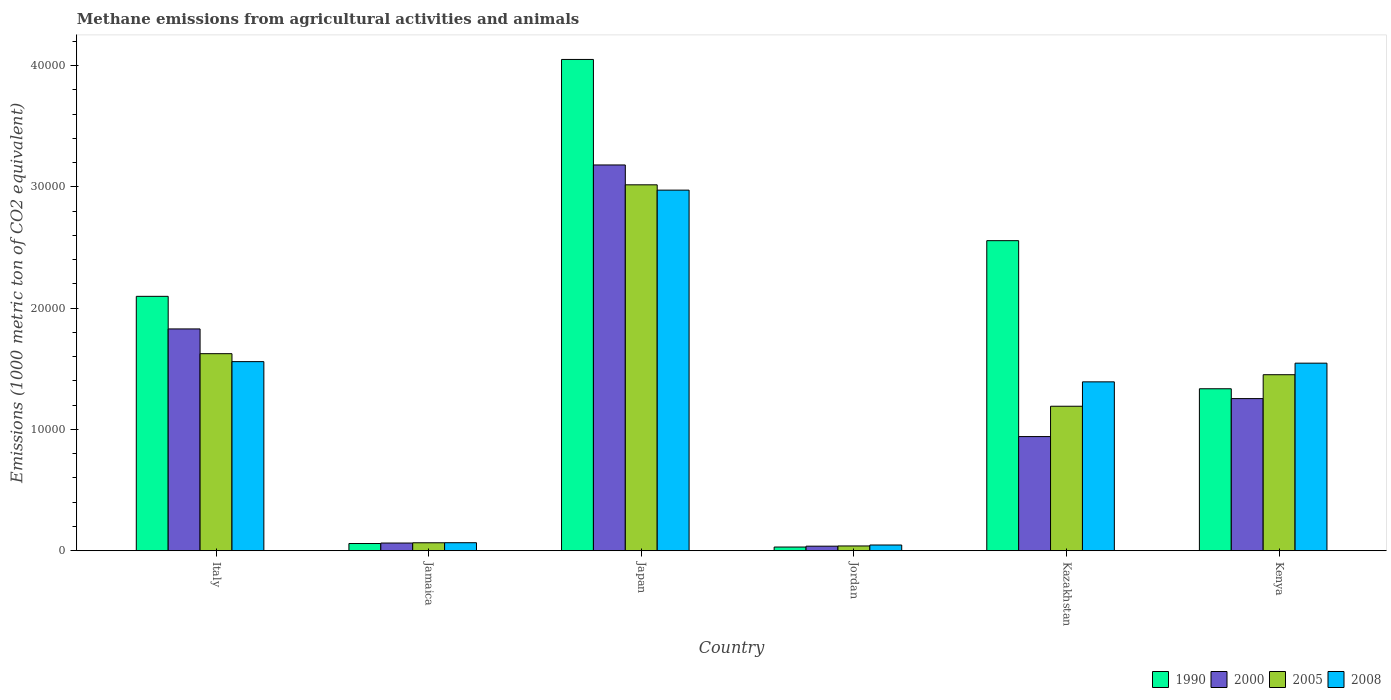How many groups of bars are there?
Provide a short and direct response. 6. How many bars are there on the 5th tick from the left?
Keep it short and to the point. 4. How many bars are there on the 3rd tick from the right?
Provide a succinct answer. 4. What is the label of the 4th group of bars from the left?
Your response must be concise. Jordan. What is the amount of methane emitted in 2008 in Jordan?
Provide a short and direct response. 470.4. Across all countries, what is the maximum amount of methane emitted in 2008?
Offer a terse response. 2.97e+04. Across all countries, what is the minimum amount of methane emitted in 1990?
Your answer should be compact. 303.3. In which country was the amount of methane emitted in 2008 maximum?
Ensure brevity in your answer.  Japan. In which country was the amount of methane emitted in 2000 minimum?
Your answer should be compact. Jordan. What is the total amount of methane emitted in 1990 in the graph?
Provide a short and direct response. 1.01e+05. What is the difference between the amount of methane emitted in 2005 in Jamaica and that in Kazakhstan?
Keep it short and to the point. -1.13e+04. What is the difference between the amount of methane emitted in 1990 in Jamaica and the amount of methane emitted in 2008 in Italy?
Your answer should be compact. -1.50e+04. What is the average amount of methane emitted in 2005 per country?
Offer a terse response. 1.23e+04. What is the difference between the amount of methane emitted of/in 2000 and amount of methane emitted of/in 2005 in Italy?
Keep it short and to the point. 2040.5. In how many countries, is the amount of methane emitted in 2000 greater than 16000 1000 metric ton?
Provide a succinct answer. 2. What is the ratio of the amount of methane emitted in 2005 in Japan to that in Jordan?
Keep it short and to the point. 77.01. Is the amount of methane emitted in 2000 in Jamaica less than that in Japan?
Your response must be concise. Yes. What is the difference between the highest and the second highest amount of methane emitted in 1990?
Keep it short and to the point. 1.49e+04. What is the difference between the highest and the lowest amount of methane emitted in 2000?
Keep it short and to the point. 3.14e+04. In how many countries, is the amount of methane emitted in 2000 greater than the average amount of methane emitted in 2000 taken over all countries?
Keep it short and to the point. 3. Is the sum of the amount of methane emitted in 1990 in Jamaica and Kazakhstan greater than the maximum amount of methane emitted in 2000 across all countries?
Give a very brief answer. No. Is it the case that in every country, the sum of the amount of methane emitted in 2005 and amount of methane emitted in 1990 is greater than the sum of amount of methane emitted in 2008 and amount of methane emitted in 2000?
Provide a succinct answer. No. What does the 1st bar from the right in Kenya represents?
Your answer should be compact. 2008. How many bars are there?
Your response must be concise. 24. What is the difference between two consecutive major ticks on the Y-axis?
Provide a succinct answer. 10000. Does the graph contain any zero values?
Provide a succinct answer. No. Does the graph contain grids?
Give a very brief answer. No. How many legend labels are there?
Offer a very short reply. 4. How are the legend labels stacked?
Your answer should be very brief. Horizontal. What is the title of the graph?
Your answer should be very brief. Methane emissions from agricultural activities and animals. Does "2009" appear as one of the legend labels in the graph?
Provide a short and direct response. No. What is the label or title of the X-axis?
Keep it short and to the point. Country. What is the label or title of the Y-axis?
Provide a succinct answer. Emissions (1000 metric ton of CO2 equivalent). What is the Emissions (1000 metric ton of CO2 equivalent) of 1990 in Italy?
Offer a very short reply. 2.10e+04. What is the Emissions (1000 metric ton of CO2 equivalent) of 2000 in Italy?
Keep it short and to the point. 1.83e+04. What is the Emissions (1000 metric ton of CO2 equivalent) in 2005 in Italy?
Your answer should be compact. 1.62e+04. What is the Emissions (1000 metric ton of CO2 equivalent) in 2008 in Italy?
Your response must be concise. 1.56e+04. What is the Emissions (1000 metric ton of CO2 equivalent) of 1990 in Jamaica?
Give a very brief answer. 593.6. What is the Emissions (1000 metric ton of CO2 equivalent) in 2000 in Jamaica?
Your answer should be compact. 632.9. What is the Emissions (1000 metric ton of CO2 equivalent) of 2005 in Jamaica?
Your answer should be very brief. 655.6. What is the Emissions (1000 metric ton of CO2 equivalent) of 2008 in Jamaica?
Your answer should be compact. 660.8. What is the Emissions (1000 metric ton of CO2 equivalent) of 1990 in Japan?
Provide a succinct answer. 4.05e+04. What is the Emissions (1000 metric ton of CO2 equivalent) of 2000 in Japan?
Give a very brief answer. 3.18e+04. What is the Emissions (1000 metric ton of CO2 equivalent) of 2005 in Japan?
Your response must be concise. 3.02e+04. What is the Emissions (1000 metric ton of CO2 equivalent) in 2008 in Japan?
Ensure brevity in your answer.  2.97e+04. What is the Emissions (1000 metric ton of CO2 equivalent) in 1990 in Jordan?
Provide a short and direct response. 303.3. What is the Emissions (1000 metric ton of CO2 equivalent) in 2000 in Jordan?
Provide a short and direct response. 374. What is the Emissions (1000 metric ton of CO2 equivalent) in 2005 in Jordan?
Your answer should be very brief. 391.8. What is the Emissions (1000 metric ton of CO2 equivalent) of 2008 in Jordan?
Make the answer very short. 470.4. What is the Emissions (1000 metric ton of CO2 equivalent) of 1990 in Kazakhstan?
Make the answer very short. 2.56e+04. What is the Emissions (1000 metric ton of CO2 equivalent) in 2000 in Kazakhstan?
Your response must be concise. 9412.4. What is the Emissions (1000 metric ton of CO2 equivalent) of 2005 in Kazakhstan?
Provide a succinct answer. 1.19e+04. What is the Emissions (1000 metric ton of CO2 equivalent) in 2008 in Kazakhstan?
Provide a succinct answer. 1.39e+04. What is the Emissions (1000 metric ton of CO2 equivalent) in 1990 in Kenya?
Offer a terse response. 1.34e+04. What is the Emissions (1000 metric ton of CO2 equivalent) of 2000 in Kenya?
Give a very brief answer. 1.25e+04. What is the Emissions (1000 metric ton of CO2 equivalent) in 2005 in Kenya?
Your answer should be very brief. 1.45e+04. What is the Emissions (1000 metric ton of CO2 equivalent) in 2008 in Kenya?
Make the answer very short. 1.55e+04. Across all countries, what is the maximum Emissions (1000 metric ton of CO2 equivalent) in 1990?
Your answer should be very brief. 4.05e+04. Across all countries, what is the maximum Emissions (1000 metric ton of CO2 equivalent) of 2000?
Keep it short and to the point. 3.18e+04. Across all countries, what is the maximum Emissions (1000 metric ton of CO2 equivalent) of 2005?
Offer a very short reply. 3.02e+04. Across all countries, what is the maximum Emissions (1000 metric ton of CO2 equivalent) in 2008?
Offer a very short reply. 2.97e+04. Across all countries, what is the minimum Emissions (1000 metric ton of CO2 equivalent) in 1990?
Offer a very short reply. 303.3. Across all countries, what is the minimum Emissions (1000 metric ton of CO2 equivalent) of 2000?
Provide a succinct answer. 374. Across all countries, what is the minimum Emissions (1000 metric ton of CO2 equivalent) of 2005?
Your answer should be compact. 391.8. Across all countries, what is the minimum Emissions (1000 metric ton of CO2 equivalent) of 2008?
Your answer should be compact. 470.4. What is the total Emissions (1000 metric ton of CO2 equivalent) in 1990 in the graph?
Your answer should be compact. 1.01e+05. What is the total Emissions (1000 metric ton of CO2 equivalent) in 2000 in the graph?
Offer a very short reply. 7.31e+04. What is the total Emissions (1000 metric ton of CO2 equivalent) of 2005 in the graph?
Your response must be concise. 7.39e+04. What is the total Emissions (1000 metric ton of CO2 equivalent) of 2008 in the graph?
Offer a terse response. 7.58e+04. What is the difference between the Emissions (1000 metric ton of CO2 equivalent) of 1990 in Italy and that in Jamaica?
Give a very brief answer. 2.04e+04. What is the difference between the Emissions (1000 metric ton of CO2 equivalent) in 2000 in Italy and that in Jamaica?
Provide a succinct answer. 1.77e+04. What is the difference between the Emissions (1000 metric ton of CO2 equivalent) in 2005 in Italy and that in Jamaica?
Make the answer very short. 1.56e+04. What is the difference between the Emissions (1000 metric ton of CO2 equivalent) in 2008 in Italy and that in Jamaica?
Your answer should be very brief. 1.49e+04. What is the difference between the Emissions (1000 metric ton of CO2 equivalent) of 1990 in Italy and that in Japan?
Provide a short and direct response. -1.95e+04. What is the difference between the Emissions (1000 metric ton of CO2 equivalent) of 2000 in Italy and that in Japan?
Provide a succinct answer. -1.35e+04. What is the difference between the Emissions (1000 metric ton of CO2 equivalent) of 2005 in Italy and that in Japan?
Your answer should be very brief. -1.39e+04. What is the difference between the Emissions (1000 metric ton of CO2 equivalent) of 2008 in Italy and that in Japan?
Give a very brief answer. -1.41e+04. What is the difference between the Emissions (1000 metric ton of CO2 equivalent) in 1990 in Italy and that in Jordan?
Offer a terse response. 2.07e+04. What is the difference between the Emissions (1000 metric ton of CO2 equivalent) of 2000 in Italy and that in Jordan?
Your response must be concise. 1.79e+04. What is the difference between the Emissions (1000 metric ton of CO2 equivalent) of 2005 in Italy and that in Jordan?
Your response must be concise. 1.59e+04. What is the difference between the Emissions (1000 metric ton of CO2 equivalent) of 2008 in Italy and that in Jordan?
Offer a very short reply. 1.51e+04. What is the difference between the Emissions (1000 metric ton of CO2 equivalent) in 1990 in Italy and that in Kazakhstan?
Your answer should be compact. -4591. What is the difference between the Emissions (1000 metric ton of CO2 equivalent) in 2000 in Italy and that in Kazakhstan?
Give a very brief answer. 8875.7. What is the difference between the Emissions (1000 metric ton of CO2 equivalent) in 2005 in Italy and that in Kazakhstan?
Your answer should be compact. 4333.9. What is the difference between the Emissions (1000 metric ton of CO2 equivalent) in 2008 in Italy and that in Kazakhstan?
Provide a short and direct response. 1666.6. What is the difference between the Emissions (1000 metric ton of CO2 equivalent) in 1990 in Italy and that in Kenya?
Provide a short and direct response. 7620.9. What is the difference between the Emissions (1000 metric ton of CO2 equivalent) of 2000 in Italy and that in Kenya?
Keep it short and to the point. 5744.5. What is the difference between the Emissions (1000 metric ton of CO2 equivalent) in 2005 in Italy and that in Kenya?
Your response must be concise. 1734.9. What is the difference between the Emissions (1000 metric ton of CO2 equivalent) in 2008 in Italy and that in Kenya?
Your response must be concise. 125.7. What is the difference between the Emissions (1000 metric ton of CO2 equivalent) of 1990 in Jamaica and that in Japan?
Keep it short and to the point. -3.99e+04. What is the difference between the Emissions (1000 metric ton of CO2 equivalent) in 2000 in Jamaica and that in Japan?
Ensure brevity in your answer.  -3.12e+04. What is the difference between the Emissions (1000 metric ton of CO2 equivalent) of 2005 in Jamaica and that in Japan?
Ensure brevity in your answer.  -2.95e+04. What is the difference between the Emissions (1000 metric ton of CO2 equivalent) in 2008 in Jamaica and that in Japan?
Provide a succinct answer. -2.91e+04. What is the difference between the Emissions (1000 metric ton of CO2 equivalent) of 1990 in Jamaica and that in Jordan?
Provide a short and direct response. 290.3. What is the difference between the Emissions (1000 metric ton of CO2 equivalent) in 2000 in Jamaica and that in Jordan?
Offer a very short reply. 258.9. What is the difference between the Emissions (1000 metric ton of CO2 equivalent) of 2005 in Jamaica and that in Jordan?
Ensure brevity in your answer.  263.8. What is the difference between the Emissions (1000 metric ton of CO2 equivalent) in 2008 in Jamaica and that in Jordan?
Your answer should be very brief. 190.4. What is the difference between the Emissions (1000 metric ton of CO2 equivalent) of 1990 in Jamaica and that in Kazakhstan?
Provide a succinct answer. -2.50e+04. What is the difference between the Emissions (1000 metric ton of CO2 equivalent) of 2000 in Jamaica and that in Kazakhstan?
Provide a short and direct response. -8779.5. What is the difference between the Emissions (1000 metric ton of CO2 equivalent) of 2005 in Jamaica and that in Kazakhstan?
Your response must be concise. -1.13e+04. What is the difference between the Emissions (1000 metric ton of CO2 equivalent) in 2008 in Jamaica and that in Kazakhstan?
Ensure brevity in your answer.  -1.33e+04. What is the difference between the Emissions (1000 metric ton of CO2 equivalent) in 1990 in Jamaica and that in Kenya?
Provide a succinct answer. -1.28e+04. What is the difference between the Emissions (1000 metric ton of CO2 equivalent) in 2000 in Jamaica and that in Kenya?
Make the answer very short. -1.19e+04. What is the difference between the Emissions (1000 metric ton of CO2 equivalent) in 2005 in Jamaica and that in Kenya?
Keep it short and to the point. -1.39e+04. What is the difference between the Emissions (1000 metric ton of CO2 equivalent) in 2008 in Jamaica and that in Kenya?
Provide a succinct answer. -1.48e+04. What is the difference between the Emissions (1000 metric ton of CO2 equivalent) in 1990 in Japan and that in Jordan?
Make the answer very short. 4.02e+04. What is the difference between the Emissions (1000 metric ton of CO2 equivalent) in 2000 in Japan and that in Jordan?
Your response must be concise. 3.14e+04. What is the difference between the Emissions (1000 metric ton of CO2 equivalent) in 2005 in Japan and that in Jordan?
Make the answer very short. 2.98e+04. What is the difference between the Emissions (1000 metric ton of CO2 equivalent) in 2008 in Japan and that in Jordan?
Keep it short and to the point. 2.93e+04. What is the difference between the Emissions (1000 metric ton of CO2 equivalent) in 1990 in Japan and that in Kazakhstan?
Keep it short and to the point. 1.49e+04. What is the difference between the Emissions (1000 metric ton of CO2 equivalent) in 2000 in Japan and that in Kazakhstan?
Provide a short and direct response. 2.24e+04. What is the difference between the Emissions (1000 metric ton of CO2 equivalent) in 2005 in Japan and that in Kazakhstan?
Give a very brief answer. 1.83e+04. What is the difference between the Emissions (1000 metric ton of CO2 equivalent) in 2008 in Japan and that in Kazakhstan?
Your answer should be very brief. 1.58e+04. What is the difference between the Emissions (1000 metric ton of CO2 equivalent) of 1990 in Japan and that in Kenya?
Your answer should be compact. 2.72e+04. What is the difference between the Emissions (1000 metric ton of CO2 equivalent) in 2000 in Japan and that in Kenya?
Ensure brevity in your answer.  1.93e+04. What is the difference between the Emissions (1000 metric ton of CO2 equivalent) of 2005 in Japan and that in Kenya?
Give a very brief answer. 1.57e+04. What is the difference between the Emissions (1000 metric ton of CO2 equivalent) in 2008 in Japan and that in Kenya?
Your response must be concise. 1.43e+04. What is the difference between the Emissions (1000 metric ton of CO2 equivalent) of 1990 in Jordan and that in Kazakhstan?
Provide a short and direct response. -2.53e+04. What is the difference between the Emissions (1000 metric ton of CO2 equivalent) in 2000 in Jordan and that in Kazakhstan?
Make the answer very short. -9038.4. What is the difference between the Emissions (1000 metric ton of CO2 equivalent) of 2005 in Jordan and that in Kazakhstan?
Make the answer very short. -1.15e+04. What is the difference between the Emissions (1000 metric ton of CO2 equivalent) of 2008 in Jordan and that in Kazakhstan?
Give a very brief answer. -1.35e+04. What is the difference between the Emissions (1000 metric ton of CO2 equivalent) in 1990 in Jordan and that in Kenya?
Ensure brevity in your answer.  -1.31e+04. What is the difference between the Emissions (1000 metric ton of CO2 equivalent) of 2000 in Jordan and that in Kenya?
Your answer should be compact. -1.22e+04. What is the difference between the Emissions (1000 metric ton of CO2 equivalent) of 2005 in Jordan and that in Kenya?
Your response must be concise. -1.41e+04. What is the difference between the Emissions (1000 metric ton of CO2 equivalent) of 2008 in Jordan and that in Kenya?
Provide a short and direct response. -1.50e+04. What is the difference between the Emissions (1000 metric ton of CO2 equivalent) in 1990 in Kazakhstan and that in Kenya?
Your answer should be compact. 1.22e+04. What is the difference between the Emissions (1000 metric ton of CO2 equivalent) in 2000 in Kazakhstan and that in Kenya?
Keep it short and to the point. -3131.2. What is the difference between the Emissions (1000 metric ton of CO2 equivalent) in 2005 in Kazakhstan and that in Kenya?
Provide a short and direct response. -2599. What is the difference between the Emissions (1000 metric ton of CO2 equivalent) of 2008 in Kazakhstan and that in Kenya?
Ensure brevity in your answer.  -1540.9. What is the difference between the Emissions (1000 metric ton of CO2 equivalent) of 1990 in Italy and the Emissions (1000 metric ton of CO2 equivalent) of 2000 in Jamaica?
Offer a very short reply. 2.03e+04. What is the difference between the Emissions (1000 metric ton of CO2 equivalent) of 1990 in Italy and the Emissions (1000 metric ton of CO2 equivalent) of 2005 in Jamaica?
Your answer should be compact. 2.03e+04. What is the difference between the Emissions (1000 metric ton of CO2 equivalent) in 1990 in Italy and the Emissions (1000 metric ton of CO2 equivalent) in 2008 in Jamaica?
Ensure brevity in your answer.  2.03e+04. What is the difference between the Emissions (1000 metric ton of CO2 equivalent) of 2000 in Italy and the Emissions (1000 metric ton of CO2 equivalent) of 2005 in Jamaica?
Offer a terse response. 1.76e+04. What is the difference between the Emissions (1000 metric ton of CO2 equivalent) of 2000 in Italy and the Emissions (1000 metric ton of CO2 equivalent) of 2008 in Jamaica?
Provide a short and direct response. 1.76e+04. What is the difference between the Emissions (1000 metric ton of CO2 equivalent) in 2005 in Italy and the Emissions (1000 metric ton of CO2 equivalent) in 2008 in Jamaica?
Offer a terse response. 1.56e+04. What is the difference between the Emissions (1000 metric ton of CO2 equivalent) of 1990 in Italy and the Emissions (1000 metric ton of CO2 equivalent) of 2000 in Japan?
Your answer should be very brief. -1.08e+04. What is the difference between the Emissions (1000 metric ton of CO2 equivalent) of 1990 in Italy and the Emissions (1000 metric ton of CO2 equivalent) of 2005 in Japan?
Give a very brief answer. -9195.3. What is the difference between the Emissions (1000 metric ton of CO2 equivalent) of 1990 in Italy and the Emissions (1000 metric ton of CO2 equivalent) of 2008 in Japan?
Provide a short and direct response. -8758. What is the difference between the Emissions (1000 metric ton of CO2 equivalent) of 2000 in Italy and the Emissions (1000 metric ton of CO2 equivalent) of 2005 in Japan?
Ensure brevity in your answer.  -1.19e+04. What is the difference between the Emissions (1000 metric ton of CO2 equivalent) in 2000 in Italy and the Emissions (1000 metric ton of CO2 equivalent) in 2008 in Japan?
Provide a short and direct response. -1.14e+04. What is the difference between the Emissions (1000 metric ton of CO2 equivalent) of 2005 in Italy and the Emissions (1000 metric ton of CO2 equivalent) of 2008 in Japan?
Keep it short and to the point. -1.35e+04. What is the difference between the Emissions (1000 metric ton of CO2 equivalent) of 1990 in Italy and the Emissions (1000 metric ton of CO2 equivalent) of 2000 in Jordan?
Offer a very short reply. 2.06e+04. What is the difference between the Emissions (1000 metric ton of CO2 equivalent) in 1990 in Italy and the Emissions (1000 metric ton of CO2 equivalent) in 2005 in Jordan?
Your answer should be compact. 2.06e+04. What is the difference between the Emissions (1000 metric ton of CO2 equivalent) in 1990 in Italy and the Emissions (1000 metric ton of CO2 equivalent) in 2008 in Jordan?
Make the answer very short. 2.05e+04. What is the difference between the Emissions (1000 metric ton of CO2 equivalent) in 2000 in Italy and the Emissions (1000 metric ton of CO2 equivalent) in 2005 in Jordan?
Ensure brevity in your answer.  1.79e+04. What is the difference between the Emissions (1000 metric ton of CO2 equivalent) in 2000 in Italy and the Emissions (1000 metric ton of CO2 equivalent) in 2008 in Jordan?
Provide a short and direct response. 1.78e+04. What is the difference between the Emissions (1000 metric ton of CO2 equivalent) in 2005 in Italy and the Emissions (1000 metric ton of CO2 equivalent) in 2008 in Jordan?
Your response must be concise. 1.58e+04. What is the difference between the Emissions (1000 metric ton of CO2 equivalent) in 1990 in Italy and the Emissions (1000 metric ton of CO2 equivalent) in 2000 in Kazakhstan?
Offer a very short reply. 1.16e+04. What is the difference between the Emissions (1000 metric ton of CO2 equivalent) in 1990 in Italy and the Emissions (1000 metric ton of CO2 equivalent) in 2005 in Kazakhstan?
Keep it short and to the point. 9061.7. What is the difference between the Emissions (1000 metric ton of CO2 equivalent) in 1990 in Italy and the Emissions (1000 metric ton of CO2 equivalent) in 2008 in Kazakhstan?
Provide a short and direct response. 7050.5. What is the difference between the Emissions (1000 metric ton of CO2 equivalent) in 2000 in Italy and the Emissions (1000 metric ton of CO2 equivalent) in 2005 in Kazakhstan?
Your answer should be compact. 6374.4. What is the difference between the Emissions (1000 metric ton of CO2 equivalent) in 2000 in Italy and the Emissions (1000 metric ton of CO2 equivalent) in 2008 in Kazakhstan?
Ensure brevity in your answer.  4363.2. What is the difference between the Emissions (1000 metric ton of CO2 equivalent) in 2005 in Italy and the Emissions (1000 metric ton of CO2 equivalent) in 2008 in Kazakhstan?
Offer a very short reply. 2322.7. What is the difference between the Emissions (1000 metric ton of CO2 equivalent) of 1990 in Italy and the Emissions (1000 metric ton of CO2 equivalent) of 2000 in Kenya?
Your answer should be very brief. 8431.8. What is the difference between the Emissions (1000 metric ton of CO2 equivalent) of 1990 in Italy and the Emissions (1000 metric ton of CO2 equivalent) of 2005 in Kenya?
Your answer should be compact. 6462.7. What is the difference between the Emissions (1000 metric ton of CO2 equivalent) of 1990 in Italy and the Emissions (1000 metric ton of CO2 equivalent) of 2008 in Kenya?
Give a very brief answer. 5509.6. What is the difference between the Emissions (1000 metric ton of CO2 equivalent) in 2000 in Italy and the Emissions (1000 metric ton of CO2 equivalent) in 2005 in Kenya?
Your answer should be compact. 3775.4. What is the difference between the Emissions (1000 metric ton of CO2 equivalent) in 2000 in Italy and the Emissions (1000 metric ton of CO2 equivalent) in 2008 in Kenya?
Ensure brevity in your answer.  2822.3. What is the difference between the Emissions (1000 metric ton of CO2 equivalent) in 2005 in Italy and the Emissions (1000 metric ton of CO2 equivalent) in 2008 in Kenya?
Provide a succinct answer. 781.8. What is the difference between the Emissions (1000 metric ton of CO2 equivalent) in 1990 in Jamaica and the Emissions (1000 metric ton of CO2 equivalent) in 2000 in Japan?
Provide a short and direct response. -3.12e+04. What is the difference between the Emissions (1000 metric ton of CO2 equivalent) in 1990 in Jamaica and the Emissions (1000 metric ton of CO2 equivalent) in 2005 in Japan?
Give a very brief answer. -2.96e+04. What is the difference between the Emissions (1000 metric ton of CO2 equivalent) of 1990 in Jamaica and the Emissions (1000 metric ton of CO2 equivalent) of 2008 in Japan?
Offer a terse response. -2.91e+04. What is the difference between the Emissions (1000 metric ton of CO2 equivalent) in 2000 in Jamaica and the Emissions (1000 metric ton of CO2 equivalent) in 2005 in Japan?
Provide a succinct answer. -2.95e+04. What is the difference between the Emissions (1000 metric ton of CO2 equivalent) of 2000 in Jamaica and the Emissions (1000 metric ton of CO2 equivalent) of 2008 in Japan?
Your answer should be very brief. -2.91e+04. What is the difference between the Emissions (1000 metric ton of CO2 equivalent) in 2005 in Jamaica and the Emissions (1000 metric ton of CO2 equivalent) in 2008 in Japan?
Your answer should be very brief. -2.91e+04. What is the difference between the Emissions (1000 metric ton of CO2 equivalent) of 1990 in Jamaica and the Emissions (1000 metric ton of CO2 equivalent) of 2000 in Jordan?
Provide a short and direct response. 219.6. What is the difference between the Emissions (1000 metric ton of CO2 equivalent) in 1990 in Jamaica and the Emissions (1000 metric ton of CO2 equivalent) in 2005 in Jordan?
Offer a very short reply. 201.8. What is the difference between the Emissions (1000 metric ton of CO2 equivalent) in 1990 in Jamaica and the Emissions (1000 metric ton of CO2 equivalent) in 2008 in Jordan?
Provide a succinct answer. 123.2. What is the difference between the Emissions (1000 metric ton of CO2 equivalent) of 2000 in Jamaica and the Emissions (1000 metric ton of CO2 equivalent) of 2005 in Jordan?
Give a very brief answer. 241.1. What is the difference between the Emissions (1000 metric ton of CO2 equivalent) of 2000 in Jamaica and the Emissions (1000 metric ton of CO2 equivalent) of 2008 in Jordan?
Ensure brevity in your answer.  162.5. What is the difference between the Emissions (1000 metric ton of CO2 equivalent) in 2005 in Jamaica and the Emissions (1000 metric ton of CO2 equivalent) in 2008 in Jordan?
Ensure brevity in your answer.  185.2. What is the difference between the Emissions (1000 metric ton of CO2 equivalent) of 1990 in Jamaica and the Emissions (1000 metric ton of CO2 equivalent) of 2000 in Kazakhstan?
Your answer should be very brief. -8818.8. What is the difference between the Emissions (1000 metric ton of CO2 equivalent) in 1990 in Jamaica and the Emissions (1000 metric ton of CO2 equivalent) in 2005 in Kazakhstan?
Your answer should be very brief. -1.13e+04. What is the difference between the Emissions (1000 metric ton of CO2 equivalent) of 1990 in Jamaica and the Emissions (1000 metric ton of CO2 equivalent) of 2008 in Kazakhstan?
Offer a terse response. -1.33e+04. What is the difference between the Emissions (1000 metric ton of CO2 equivalent) in 2000 in Jamaica and the Emissions (1000 metric ton of CO2 equivalent) in 2005 in Kazakhstan?
Give a very brief answer. -1.13e+04. What is the difference between the Emissions (1000 metric ton of CO2 equivalent) in 2000 in Jamaica and the Emissions (1000 metric ton of CO2 equivalent) in 2008 in Kazakhstan?
Your answer should be compact. -1.33e+04. What is the difference between the Emissions (1000 metric ton of CO2 equivalent) of 2005 in Jamaica and the Emissions (1000 metric ton of CO2 equivalent) of 2008 in Kazakhstan?
Make the answer very short. -1.33e+04. What is the difference between the Emissions (1000 metric ton of CO2 equivalent) of 1990 in Jamaica and the Emissions (1000 metric ton of CO2 equivalent) of 2000 in Kenya?
Give a very brief answer. -1.20e+04. What is the difference between the Emissions (1000 metric ton of CO2 equivalent) in 1990 in Jamaica and the Emissions (1000 metric ton of CO2 equivalent) in 2005 in Kenya?
Offer a very short reply. -1.39e+04. What is the difference between the Emissions (1000 metric ton of CO2 equivalent) of 1990 in Jamaica and the Emissions (1000 metric ton of CO2 equivalent) of 2008 in Kenya?
Your answer should be compact. -1.49e+04. What is the difference between the Emissions (1000 metric ton of CO2 equivalent) in 2000 in Jamaica and the Emissions (1000 metric ton of CO2 equivalent) in 2005 in Kenya?
Provide a short and direct response. -1.39e+04. What is the difference between the Emissions (1000 metric ton of CO2 equivalent) in 2000 in Jamaica and the Emissions (1000 metric ton of CO2 equivalent) in 2008 in Kenya?
Ensure brevity in your answer.  -1.48e+04. What is the difference between the Emissions (1000 metric ton of CO2 equivalent) in 2005 in Jamaica and the Emissions (1000 metric ton of CO2 equivalent) in 2008 in Kenya?
Offer a very short reply. -1.48e+04. What is the difference between the Emissions (1000 metric ton of CO2 equivalent) in 1990 in Japan and the Emissions (1000 metric ton of CO2 equivalent) in 2000 in Jordan?
Provide a short and direct response. 4.01e+04. What is the difference between the Emissions (1000 metric ton of CO2 equivalent) of 1990 in Japan and the Emissions (1000 metric ton of CO2 equivalent) of 2005 in Jordan?
Your response must be concise. 4.01e+04. What is the difference between the Emissions (1000 metric ton of CO2 equivalent) of 1990 in Japan and the Emissions (1000 metric ton of CO2 equivalent) of 2008 in Jordan?
Your response must be concise. 4.00e+04. What is the difference between the Emissions (1000 metric ton of CO2 equivalent) in 2000 in Japan and the Emissions (1000 metric ton of CO2 equivalent) in 2005 in Jordan?
Make the answer very short. 3.14e+04. What is the difference between the Emissions (1000 metric ton of CO2 equivalent) of 2000 in Japan and the Emissions (1000 metric ton of CO2 equivalent) of 2008 in Jordan?
Make the answer very short. 3.13e+04. What is the difference between the Emissions (1000 metric ton of CO2 equivalent) of 2005 in Japan and the Emissions (1000 metric ton of CO2 equivalent) of 2008 in Jordan?
Your response must be concise. 2.97e+04. What is the difference between the Emissions (1000 metric ton of CO2 equivalent) of 1990 in Japan and the Emissions (1000 metric ton of CO2 equivalent) of 2000 in Kazakhstan?
Make the answer very short. 3.11e+04. What is the difference between the Emissions (1000 metric ton of CO2 equivalent) in 1990 in Japan and the Emissions (1000 metric ton of CO2 equivalent) in 2005 in Kazakhstan?
Ensure brevity in your answer.  2.86e+04. What is the difference between the Emissions (1000 metric ton of CO2 equivalent) in 1990 in Japan and the Emissions (1000 metric ton of CO2 equivalent) in 2008 in Kazakhstan?
Provide a succinct answer. 2.66e+04. What is the difference between the Emissions (1000 metric ton of CO2 equivalent) of 2000 in Japan and the Emissions (1000 metric ton of CO2 equivalent) of 2005 in Kazakhstan?
Make the answer very short. 1.99e+04. What is the difference between the Emissions (1000 metric ton of CO2 equivalent) of 2000 in Japan and the Emissions (1000 metric ton of CO2 equivalent) of 2008 in Kazakhstan?
Keep it short and to the point. 1.79e+04. What is the difference between the Emissions (1000 metric ton of CO2 equivalent) in 2005 in Japan and the Emissions (1000 metric ton of CO2 equivalent) in 2008 in Kazakhstan?
Give a very brief answer. 1.62e+04. What is the difference between the Emissions (1000 metric ton of CO2 equivalent) in 1990 in Japan and the Emissions (1000 metric ton of CO2 equivalent) in 2000 in Kenya?
Give a very brief answer. 2.80e+04. What is the difference between the Emissions (1000 metric ton of CO2 equivalent) of 1990 in Japan and the Emissions (1000 metric ton of CO2 equivalent) of 2005 in Kenya?
Make the answer very short. 2.60e+04. What is the difference between the Emissions (1000 metric ton of CO2 equivalent) in 1990 in Japan and the Emissions (1000 metric ton of CO2 equivalent) in 2008 in Kenya?
Your answer should be very brief. 2.50e+04. What is the difference between the Emissions (1000 metric ton of CO2 equivalent) of 2000 in Japan and the Emissions (1000 metric ton of CO2 equivalent) of 2005 in Kenya?
Give a very brief answer. 1.73e+04. What is the difference between the Emissions (1000 metric ton of CO2 equivalent) of 2000 in Japan and the Emissions (1000 metric ton of CO2 equivalent) of 2008 in Kenya?
Your answer should be compact. 1.63e+04. What is the difference between the Emissions (1000 metric ton of CO2 equivalent) in 2005 in Japan and the Emissions (1000 metric ton of CO2 equivalent) in 2008 in Kenya?
Your answer should be very brief. 1.47e+04. What is the difference between the Emissions (1000 metric ton of CO2 equivalent) in 1990 in Jordan and the Emissions (1000 metric ton of CO2 equivalent) in 2000 in Kazakhstan?
Provide a short and direct response. -9109.1. What is the difference between the Emissions (1000 metric ton of CO2 equivalent) of 1990 in Jordan and the Emissions (1000 metric ton of CO2 equivalent) of 2005 in Kazakhstan?
Give a very brief answer. -1.16e+04. What is the difference between the Emissions (1000 metric ton of CO2 equivalent) of 1990 in Jordan and the Emissions (1000 metric ton of CO2 equivalent) of 2008 in Kazakhstan?
Give a very brief answer. -1.36e+04. What is the difference between the Emissions (1000 metric ton of CO2 equivalent) of 2000 in Jordan and the Emissions (1000 metric ton of CO2 equivalent) of 2005 in Kazakhstan?
Provide a short and direct response. -1.15e+04. What is the difference between the Emissions (1000 metric ton of CO2 equivalent) of 2000 in Jordan and the Emissions (1000 metric ton of CO2 equivalent) of 2008 in Kazakhstan?
Make the answer very short. -1.36e+04. What is the difference between the Emissions (1000 metric ton of CO2 equivalent) in 2005 in Jordan and the Emissions (1000 metric ton of CO2 equivalent) in 2008 in Kazakhstan?
Provide a short and direct response. -1.35e+04. What is the difference between the Emissions (1000 metric ton of CO2 equivalent) of 1990 in Jordan and the Emissions (1000 metric ton of CO2 equivalent) of 2000 in Kenya?
Provide a short and direct response. -1.22e+04. What is the difference between the Emissions (1000 metric ton of CO2 equivalent) of 1990 in Jordan and the Emissions (1000 metric ton of CO2 equivalent) of 2005 in Kenya?
Your answer should be compact. -1.42e+04. What is the difference between the Emissions (1000 metric ton of CO2 equivalent) in 1990 in Jordan and the Emissions (1000 metric ton of CO2 equivalent) in 2008 in Kenya?
Give a very brief answer. -1.52e+04. What is the difference between the Emissions (1000 metric ton of CO2 equivalent) in 2000 in Jordan and the Emissions (1000 metric ton of CO2 equivalent) in 2005 in Kenya?
Give a very brief answer. -1.41e+04. What is the difference between the Emissions (1000 metric ton of CO2 equivalent) in 2000 in Jordan and the Emissions (1000 metric ton of CO2 equivalent) in 2008 in Kenya?
Give a very brief answer. -1.51e+04. What is the difference between the Emissions (1000 metric ton of CO2 equivalent) of 2005 in Jordan and the Emissions (1000 metric ton of CO2 equivalent) of 2008 in Kenya?
Make the answer very short. -1.51e+04. What is the difference between the Emissions (1000 metric ton of CO2 equivalent) in 1990 in Kazakhstan and the Emissions (1000 metric ton of CO2 equivalent) in 2000 in Kenya?
Offer a very short reply. 1.30e+04. What is the difference between the Emissions (1000 metric ton of CO2 equivalent) of 1990 in Kazakhstan and the Emissions (1000 metric ton of CO2 equivalent) of 2005 in Kenya?
Your response must be concise. 1.11e+04. What is the difference between the Emissions (1000 metric ton of CO2 equivalent) in 1990 in Kazakhstan and the Emissions (1000 metric ton of CO2 equivalent) in 2008 in Kenya?
Offer a terse response. 1.01e+04. What is the difference between the Emissions (1000 metric ton of CO2 equivalent) in 2000 in Kazakhstan and the Emissions (1000 metric ton of CO2 equivalent) in 2005 in Kenya?
Provide a succinct answer. -5100.3. What is the difference between the Emissions (1000 metric ton of CO2 equivalent) of 2000 in Kazakhstan and the Emissions (1000 metric ton of CO2 equivalent) of 2008 in Kenya?
Your answer should be compact. -6053.4. What is the difference between the Emissions (1000 metric ton of CO2 equivalent) in 2005 in Kazakhstan and the Emissions (1000 metric ton of CO2 equivalent) in 2008 in Kenya?
Make the answer very short. -3552.1. What is the average Emissions (1000 metric ton of CO2 equivalent) of 1990 per country?
Make the answer very short. 1.69e+04. What is the average Emissions (1000 metric ton of CO2 equivalent) of 2000 per country?
Keep it short and to the point. 1.22e+04. What is the average Emissions (1000 metric ton of CO2 equivalent) in 2005 per country?
Offer a terse response. 1.23e+04. What is the average Emissions (1000 metric ton of CO2 equivalent) in 2008 per country?
Provide a succinct answer. 1.26e+04. What is the difference between the Emissions (1000 metric ton of CO2 equivalent) in 1990 and Emissions (1000 metric ton of CO2 equivalent) in 2000 in Italy?
Your answer should be compact. 2687.3. What is the difference between the Emissions (1000 metric ton of CO2 equivalent) in 1990 and Emissions (1000 metric ton of CO2 equivalent) in 2005 in Italy?
Make the answer very short. 4727.8. What is the difference between the Emissions (1000 metric ton of CO2 equivalent) in 1990 and Emissions (1000 metric ton of CO2 equivalent) in 2008 in Italy?
Make the answer very short. 5383.9. What is the difference between the Emissions (1000 metric ton of CO2 equivalent) of 2000 and Emissions (1000 metric ton of CO2 equivalent) of 2005 in Italy?
Give a very brief answer. 2040.5. What is the difference between the Emissions (1000 metric ton of CO2 equivalent) in 2000 and Emissions (1000 metric ton of CO2 equivalent) in 2008 in Italy?
Offer a terse response. 2696.6. What is the difference between the Emissions (1000 metric ton of CO2 equivalent) in 2005 and Emissions (1000 metric ton of CO2 equivalent) in 2008 in Italy?
Ensure brevity in your answer.  656.1. What is the difference between the Emissions (1000 metric ton of CO2 equivalent) of 1990 and Emissions (1000 metric ton of CO2 equivalent) of 2000 in Jamaica?
Offer a very short reply. -39.3. What is the difference between the Emissions (1000 metric ton of CO2 equivalent) in 1990 and Emissions (1000 metric ton of CO2 equivalent) in 2005 in Jamaica?
Ensure brevity in your answer.  -62. What is the difference between the Emissions (1000 metric ton of CO2 equivalent) in 1990 and Emissions (1000 metric ton of CO2 equivalent) in 2008 in Jamaica?
Give a very brief answer. -67.2. What is the difference between the Emissions (1000 metric ton of CO2 equivalent) in 2000 and Emissions (1000 metric ton of CO2 equivalent) in 2005 in Jamaica?
Offer a terse response. -22.7. What is the difference between the Emissions (1000 metric ton of CO2 equivalent) of 2000 and Emissions (1000 metric ton of CO2 equivalent) of 2008 in Jamaica?
Offer a very short reply. -27.9. What is the difference between the Emissions (1000 metric ton of CO2 equivalent) in 2005 and Emissions (1000 metric ton of CO2 equivalent) in 2008 in Jamaica?
Provide a succinct answer. -5.2. What is the difference between the Emissions (1000 metric ton of CO2 equivalent) in 1990 and Emissions (1000 metric ton of CO2 equivalent) in 2000 in Japan?
Offer a very short reply. 8700.7. What is the difference between the Emissions (1000 metric ton of CO2 equivalent) of 1990 and Emissions (1000 metric ton of CO2 equivalent) of 2005 in Japan?
Give a very brief answer. 1.03e+04. What is the difference between the Emissions (1000 metric ton of CO2 equivalent) in 1990 and Emissions (1000 metric ton of CO2 equivalent) in 2008 in Japan?
Your response must be concise. 1.08e+04. What is the difference between the Emissions (1000 metric ton of CO2 equivalent) in 2000 and Emissions (1000 metric ton of CO2 equivalent) in 2005 in Japan?
Offer a terse response. 1638. What is the difference between the Emissions (1000 metric ton of CO2 equivalent) of 2000 and Emissions (1000 metric ton of CO2 equivalent) of 2008 in Japan?
Provide a short and direct response. 2075.3. What is the difference between the Emissions (1000 metric ton of CO2 equivalent) of 2005 and Emissions (1000 metric ton of CO2 equivalent) of 2008 in Japan?
Give a very brief answer. 437.3. What is the difference between the Emissions (1000 metric ton of CO2 equivalent) of 1990 and Emissions (1000 metric ton of CO2 equivalent) of 2000 in Jordan?
Make the answer very short. -70.7. What is the difference between the Emissions (1000 metric ton of CO2 equivalent) in 1990 and Emissions (1000 metric ton of CO2 equivalent) in 2005 in Jordan?
Provide a succinct answer. -88.5. What is the difference between the Emissions (1000 metric ton of CO2 equivalent) in 1990 and Emissions (1000 metric ton of CO2 equivalent) in 2008 in Jordan?
Keep it short and to the point. -167.1. What is the difference between the Emissions (1000 metric ton of CO2 equivalent) of 2000 and Emissions (1000 metric ton of CO2 equivalent) of 2005 in Jordan?
Your answer should be very brief. -17.8. What is the difference between the Emissions (1000 metric ton of CO2 equivalent) of 2000 and Emissions (1000 metric ton of CO2 equivalent) of 2008 in Jordan?
Make the answer very short. -96.4. What is the difference between the Emissions (1000 metric ton of CO2 equivalent) in 2005 and Emissions (1000 metric ton of CO2 equivalent) in 2008 in Jordan?
Your answer should be compact. -78.6. What is the difference between the Emissions (1000 metric ton of CO2 equivalent) of 1990 and Emissions (1000 metric ton of CO2 equivalent) of 2000 in Kazakhstan?
Your answer should be compact. 1.62e+04. What is the difference between the Emissions (1000 metric ton of CO2 equivalent) in 1990 and Emissions (1000 metric ton of CO2 equivalent) in 2005 in Kazakhstan?
Keep it short and to the point. 1.37e+04. What is the difference between the Emissions (1000 metric ton of CO2 equivalent) in 1990 and Emissions (1000 metric ton of CO2 equivalent) in 2008 in Kazakhstan?
Ensure brevity in your answer.  1.16e+04. What is the difference between the Emissions (1000 metric ton of CO2 equivalent) of 2000 and Emissions (1000 metric ton of CO2 equivalent) of 2005 in Kazakhstan?
Make the answer very short. -2501.3. What is the difference between the Emissions (1000 metric ton of CO2 equivalent) in 2000 and Emissions (1000 metric ton of CO2 equivalent) in 2008 in Kazakhstan?
Offer a very short reply. -4512.5. What is the difference between the Emissions (1000 metric ton of CO2 equivalent) of 2005 and Emissions (1000 metric ton of CO2 equivalent) of 2008 in Kazakhstan?
Your response must be concise. -2011.2. What is the difference between the Emissions (1000 metric ton of CO2 equivalent) of 1990 and Emissions (1000 metric ton of CO2 equivalent) of 2000 in Kenya?
Offer a terse response. 810.9. What is the difference between the Emissions (1000 metric ton of CO2 equivalent) of 1990 and Emissions (1000 metric ton of CO2 equivalent) of 2005 in Kenya?
Offer a terse response. -1158.2. What is the difference between the Emissions (1000 metric ton of CO2 equivalent) of 1990 and Emissions (1000 metric ton of CO2 equivalent) of 2008 in Kenya?
Offer a very short reply. -2111.3. What is the difference between the Emissions (1000 metric ton of CO2 equivalent) in 2000 and Emissions (1000 metric ton of CO2 equivalent) in 2005 in Kenya?
Your answer should be very brief. -1969.1. What is the difference between the Emissions (1000 metric ton of CO2 equivalent) of 2000 and Emissions (1000 metric ton of CO2 equivalent) of 2008 in Kenya?
Offer a very short reply. -2922.2. What is the difference between the Emissions (1000 metric ton of CO2 equivalent) of 2005 and Emissions (1000 metric ton of CO2 equivalent) of 2008 in Kenya?
Offer a terse response. -953.1. What is the ratio of the Emissions (1000 metric ton of CO2 equivalent) of 1990 in Italy to that in Jamaica?
Provide a short and direct response. 35.34. What is the ratio of the Emissions (1000 metric ton of CO2 equivalent) in 2000 in Italy to that in Jamaica?
Offer a very short reply. 28.9. What is the ratio of the Emissions (1000 metric ton of CO2 equivalent) of 2005 in Italy to that in Jamaica?
Keep it short and to the point. 24.78. What is the ratio of the Emissions (1000 metric ton of CO2 equivalent) of 2008 in Italy to that in Jamaica?
Provide a succinct answer. 23.59. What is the ratio of the Emissions (1000 metric ton of CO2 equivalent) in 1990 in Italy to that in Japan?
Ensure brevity in your answer.  0.52. What is the ratio of the Emissions (1000 metric ton of CO2 equivalent) of 2000 in Italy to that in Japan?
Offer a terse response. 0.57. What is the ratio of the Emissions (1000 metric ton of CO2 equivalent) in 2005 in Italy to that in Japan?
Your answer should be compact. 0.54. What is the ratio of the Emissions (1000 metric ton of CO2 equivalent) in 2008 in Italy to that in Japan?
Ensure brevity in your answer.  0.52. What is the ratio of the Emissions (1000 metric ton of CO2 equivalent) of 1990 in Italy to that in Jordan?
Offer a very short reply. 69.16. What is the ratio of the Emissions (1000 metric ton of CO2 equivalent) in 2000 in Italy to that in Jordan?
Keep it short and to the point. 48.9. What is the ratio of the Emissions (1000 metric ton of CO2 equivalent) in 2005 in Italy to that in Jordan?
Ensure brevity in your answer.  41.47. What is the ratio of the Emissions (1000 metric ton of CO2 equivalent) in 2008 in Italy to that in Jordan?
Your answer should be very brief. 33.15. What is the ratio of the Emissions (1000 metric ton of CO2 equivalent) in 1990 in Italy to that in Kazakhstan?
Give a very brief answer. 0.82. What is the ratio of the Emissions (1000 metric ton of CO2 equivalent) of 2000 in Italy to that in Kazakhstan?
Your answer should be very brief. 1.94. What is the ratio of the Emissions (1000 metric ton of CO2 equivalent) in 2005 in Italy to that in Kazakhstan?
Ensure brevity in your answer.  1.36. What is the ratio of the Emissions (1000 metric ton of CO2 equivalent) in 2008 in Italy to that in Kazakhstan?
Provide a succinct answer. 1.12. What is the ratio of the Emissions (1000 metric ton of CO2 equivalent) in 1990 in Italy to that in Kenya?
Make the answer very short. 1.57. What is the ratio of the Emissions (1000 metric ton of CO2 equivalent) of 2000 in Italy to that in Kenya?
Keep it short and to the point. 1.46. What is the ratio of the Emissions (1000 metric ton of CO2 equivalent) of 2005 in Italy to that in Kenya?
Ensure brevity in your answer.  1.12. What is the ratio of the Emissions (1000 metric ton of CO2 equivalent) of 1990 in Jamaica to that in Japan?
Keep it short and to the point. 0.01. What is the ratio of the Emissions (1000 metric ton of CO2 equivalent) in 2000 in Jamaica to that in Japan?
Give a very brief answer. 0.02. What is the ratio of the Emissions (1000 metric ton of CO2 equivalent) of 2005 in Jamaica to that in Japan?
Provide a short and direct response. 0.02. What is the ratio of the Emissions (1000 metric ton of CO2 equivalent) of 2008 in Jamaica to that in Japan?
Keep it short and to the point. 0.02. What is the ratio of the Emissions (1000 metric ton of CO2 equivalent) in 1990 in Jamaica to that in Jordan?
Offer a terse response. 1.96. What is the ratio of the Emissions (1000 metric ton of CO2 equivalent) in 2000 in Jamaica to that in Jordan?
Your response must be concise. 1.69. What is the ratio of the Emissions (1000 metric ton of CO2 equivalent) in 2005 in Jamaica to that in Jordan?
Offer a very short reply. 1.67. What is the ratio of the Emissions (1000 metric ton of CO2 equivalent) in 2008 in Jamaica to that in Jordan?
Your answer should be very brief. 1.4. What is the ratio of the Emissions (1000 metric ton of CO2 equivalent) of 1990 in Jamaica to that in Kazakhstan?
Your response must be concise. 0.02. What is the ratio of the Emissions (1000 metric ton of CO2 equivalent) of 2000 in Jamaica to that in Kazakhstan?
Your answer should be compact. 0.07. What is the ratio of the Emissions (1000 metric ton of CO2 equivalent) of 2005 in Jamaica to that in Kazakhstan?
Your response must be concise. 0.06. What is the ratio of the Emissions (1000 metric ton of CO2 equivalent) in 2008 in Jamaica to that in Kazakhstan?
Give a very brief answer. 0.05. What is the ratio of the Emissions (1000 metric ton of CO2 equivalent) in 1990 in Jamaica to that in Kenya?
Keep it short and to the point. 0.04. What is the ratio of the Emissions (1000 metric ton of CO2 equivalent) of 2000 in Jamaica to that in Kenya?
Offer a terse response. 0.05. What is the ratio of the Emissions (1000 metric ton of CO2 equivalent) of 2005 in Jamaica to that in Kenya?
Give a very brief answer. 0.05. What is the ratio of the Emissions (1000 metric ton of CO2 equivalent) in 2008 in Jamaica to that in Kenya?
Provide a succinct answer. 0.04. What is the ratio of the Emissions (1000 metric ton of CO2 equivalent) in 1990 in Japan to that in Jordan?
Your answer should be very brief. 133.56. What is the ratio of the Emissions (1000 metric ton of CO2 equivalent) in 2000 in Japan to that in Jordan?
Provide a succinct answer. 85.05. What is the ratio of the Emissions (1000 metric ton of CO2 equivalent) in 2005 in Japan to that in Jordan?
Your answer should be compact. 77.01. What is the ratio of the Emissions (1000 metric ton of CO2 equivalent) of 2008 in Japan to that in Jordan?
Your response must be concise. 63.21. What is the ratio of the Emissions (1000 metric ton of CO2 equivalent) in 1990 in Japan to that in Kazakhstan?
Keep it short and to the point. 1.58. What is the ratio of the Emissions (1000 metric ton of CO2 equivalent) of 2000 in Japan to that in Kazakhstan?
Ensure brevity in your answer.  3.38. What is the ratio of the Emissions (1000 metric ton of CO2 equivalent) in 2005 in Japan to that in Kazakhstan?
Make the answer very short. 2.53. What is the ratio of the Emissions (1000 metric ton of CO2 equivalent) in 2008 in Japan to that in Kazakhstan?
Offer a very short reply. 2.14. What is the ratio of the Emissions (1000 metric ton of CO2 equivalent) in 1990 in Japan to that in Kenya?
Make the answer very short. 3.03. What is the ratio of the Emissions (1000 metric ton of CO2 equivalent) of 2000 in Japan to that in Kenya?
Give a very brief answer. 2.54. What is the ratio of the Emissions (1000 metric ton of CO2 equivalent) of 2005 in Japan to that in Kenya?
Offer a very short reply. 2.08. What is the ratio of the Emissions (1000 metric ton of CO2 equivalent) of 2008 in Japan to that in Kenya?
Keep it short and to the point. 1.92. What is the ratio of the Emissions (1000 metric ton of CO2 equivalent) of 1990 in Jordan to that in Kazakhstan?
Your answer should be compact. 0.01. What is the ratio of the Emissions (1000 metric ton of CO2 equivalent) in 2000 in Jordan to that in Kazakhstan?
Give a very brief answer. 0.04. What is the ratio of the Emissions (1000 metric ton of CO2 equivalent) in 2005 in Jordan to that in Kazakhstan?
Provide a succinct answer. 0.03. What is the ratio of the Emissions (1000 metric ton of CO2 equivalent) in 2008 in Jordan to that in Kazakhstan?
Offer a terse response. 0.03. What is the ratio of the Emissions (1000 metric ton of CO2 equivalent) in 1990 in Jordan to that in Kenya?
Make the answer very short. 0.02. What is the ratio of the Emissions (1000 metric ton of CO2 equivalent) of 2000 in Jordan to that in Kenya?
Your answer should be very brief. 0.03. What is the ratio of the Emissions (1000 metric ton of CO2 equivalent) of 2005 in Jordan to that in Kenya?
Your answer should be very brief. 0.03. What is the ratio of the Emissions (1000 metric ton of CO2 equivalent) of 2008 in Jordan to that in Kenya?
Keep it short and to the point. 0.03. What is the ratio of the Emissions (1000 metric ton of CO2 equivalent) in 1990 in Kazakhstan to that in Kenya?
Your answer should be very brief. 1.91. What is the ratio of the Emissions (1000 metric ton of CO2 equivalent) in 2000 in Kazakhstan to that in Kenya?
Give a very brief answer. 0.75. What is the ratio of the Emissions (1000 metric ton of CO2 equivalent) in 2005 in Kazakhstan to that in Kenya?
Ensure brevity in your answer.  0.82. What is the ratio of the Emissions (1000 metric ton of CO2 equivalent) in 2008 in Kazakhstan to that in Kenya?
Make the answer very short. 0.9. What is the difference between the highest and the second highest Emissions (1000 metric ton of CO2 equivalent) in 1990?
Provide a short and direct response. 1.49e+04. What is the difference between the highest and the second highest Emissions (1000 metric ton of CO2 equivalent) in 2000?
Your response must be concise. 1.35e+04. What is the difference between the highest and the second highest Emissions (1000 metric ton of CO2 equivalent) of 2005?
Offer a terse response. 1.39e+04. What is the difference between the highest and the second highest Emissions (1000 metric ton of CO2 equivalent) of 2008?
Keep it short and to the point. 1.41e+04. What is the difference between the highest and the lowest Emissions (1000 metric ton of CO2 equivalent) in 1990?
Ensure brevity in your answer.  4.02e+04. What is the difference between the highest and the lowest Emissions (1000 metric ton of CO2 equivalent) of 2000?
Your response must be concise. 3.14e+04. What is the difference between the highest and the lowest Emissions (1000 metric ton of CO2 equivalent) in 2005?
Offer a very short reply. 2.98e+04. What is the difference between the highest and the lowest Emissions (1000 metric ton of CO2 equivalent) of 2008?
Make the answer very short. 2.93e+04. 